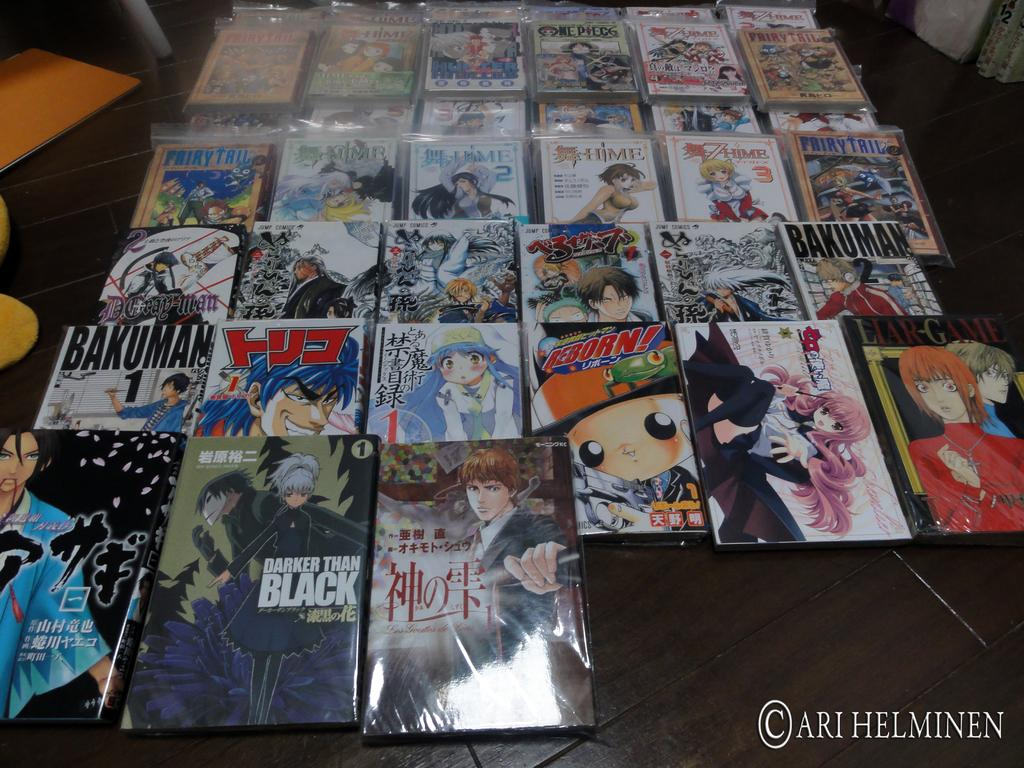<image>
Share a concise interpretation of the image provided. magazines that are different with one titled 'darker than black' 